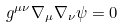<formula> <loc_0><loc_0><loc_500><loc_500>g ^ { \mu \nu } \nabla _ { \mu } \nabla _ { \nu } \psi = 0</formula> 